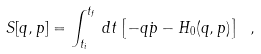Convert formula to latex. <formula><loc_0><loc_0><loc_500><loc_500>S [ q , p ] = \int _ { t _ { i } } ^ { t _ { f } } \, d t \left [ - q \dot { p } - H _ { 0 } ( q , p ) \right ] \ ,</formula> 